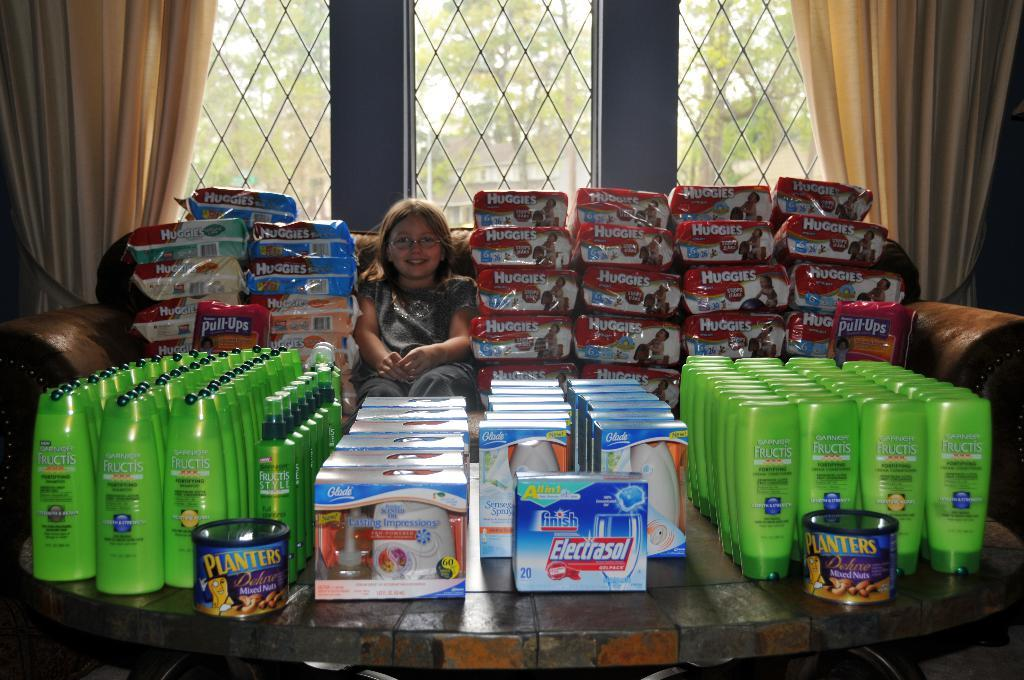<image>
Share a concise interpretation of the image provided. small girl surrounded by huggies, glade products, planters nuts, and garnier fructis shampoos 